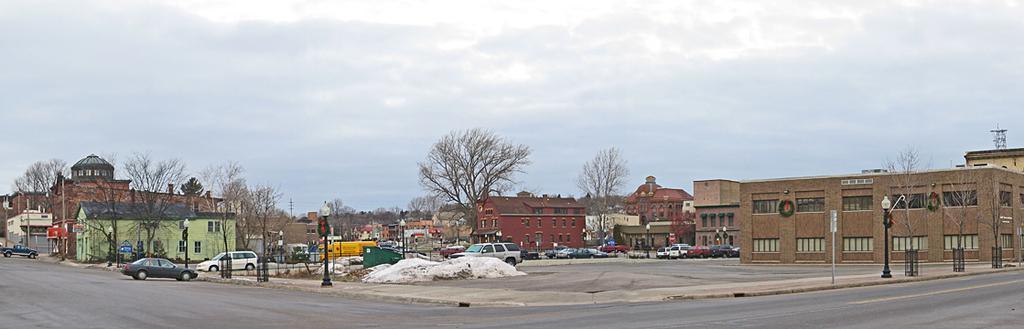How would you summarize this image in a sentence or two? In this picture we can see street lights, poles, vehicles, trees, buildings and other objects. We can see the road and the cloudy sky. 